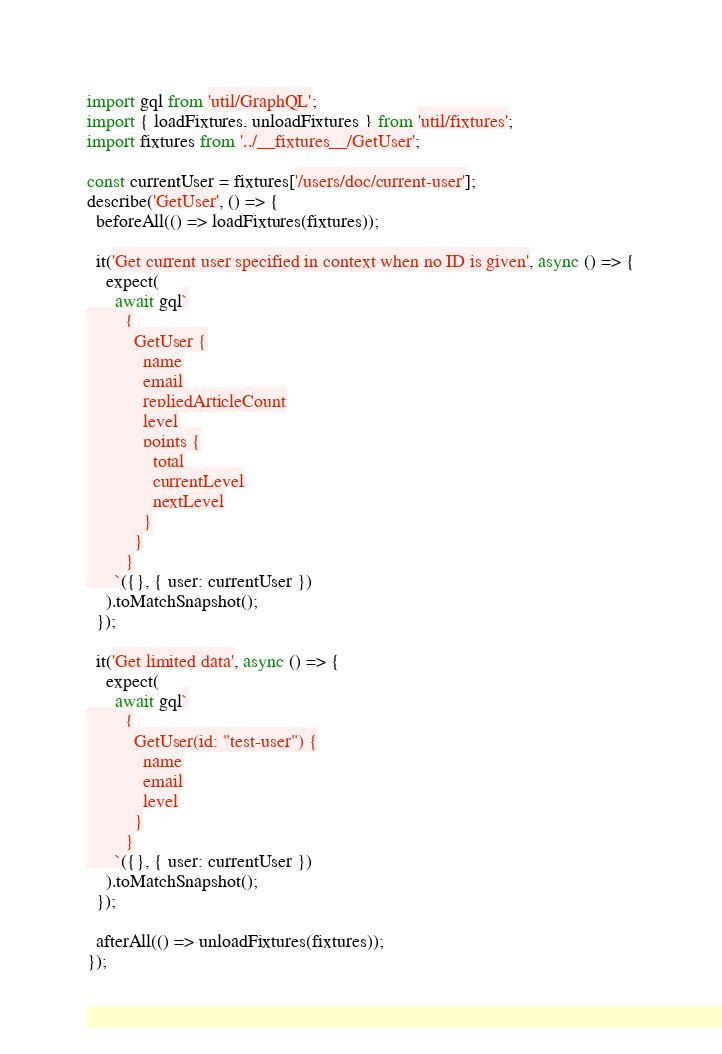<code> <loc_0><loc_0><loc_500><loc_500><_JavaScript_>import gql from 'util/GraphQL';
import { loadFixtures, unloadFixtures } from 'util/fixtures';
import fixtures from '../__fixtures__/GetUser';

const currentUser = fixtures['/users/doc/current-user'];
describe('GetUser', () => {
  beforeAll(() => loadFixtures(fixtures));

  it('Get current user specified in context when no ID is given', async () => {
    expect(
      await gql`
        {
          GetUser {
            name
            email
            repliedArticleCount
            level
            points {
              total
              currentLevel
              nextLevel
            }
          }
        }
      `({}, { user: currentUser })
    ).toMatchSnapshot();
  });

  it('Get limited data', async () => {
    expect(
      await gql`
        {
          GetUser(id: "test-user") {
            name
            email
            level
          }
        }
      `({}, { user: currentUser })
    ).toMatchSnapshot();
  });

  afterAll(() => unloadFixtures(fixtures));
});
</code> 